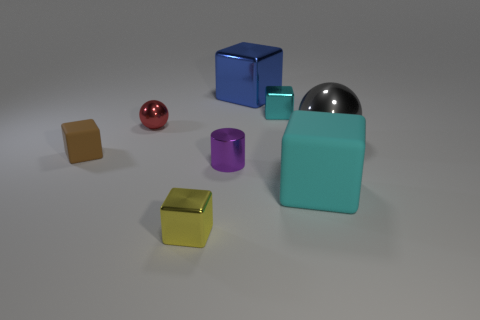Add 2 big brown rubber cylinders. How many objects exist? 10 Subtract all cylinders. How many objects are left? 7 Add 2 brown objects. How many brown objects exist? 3 Subtract 1 brown blocks. How many objects are left? 7 Subtract all tiny red shiny things. Subtract all large shiny objects. How many objects are left? 5 Add 6 large cyan things. How many large cyan things are left? 7 